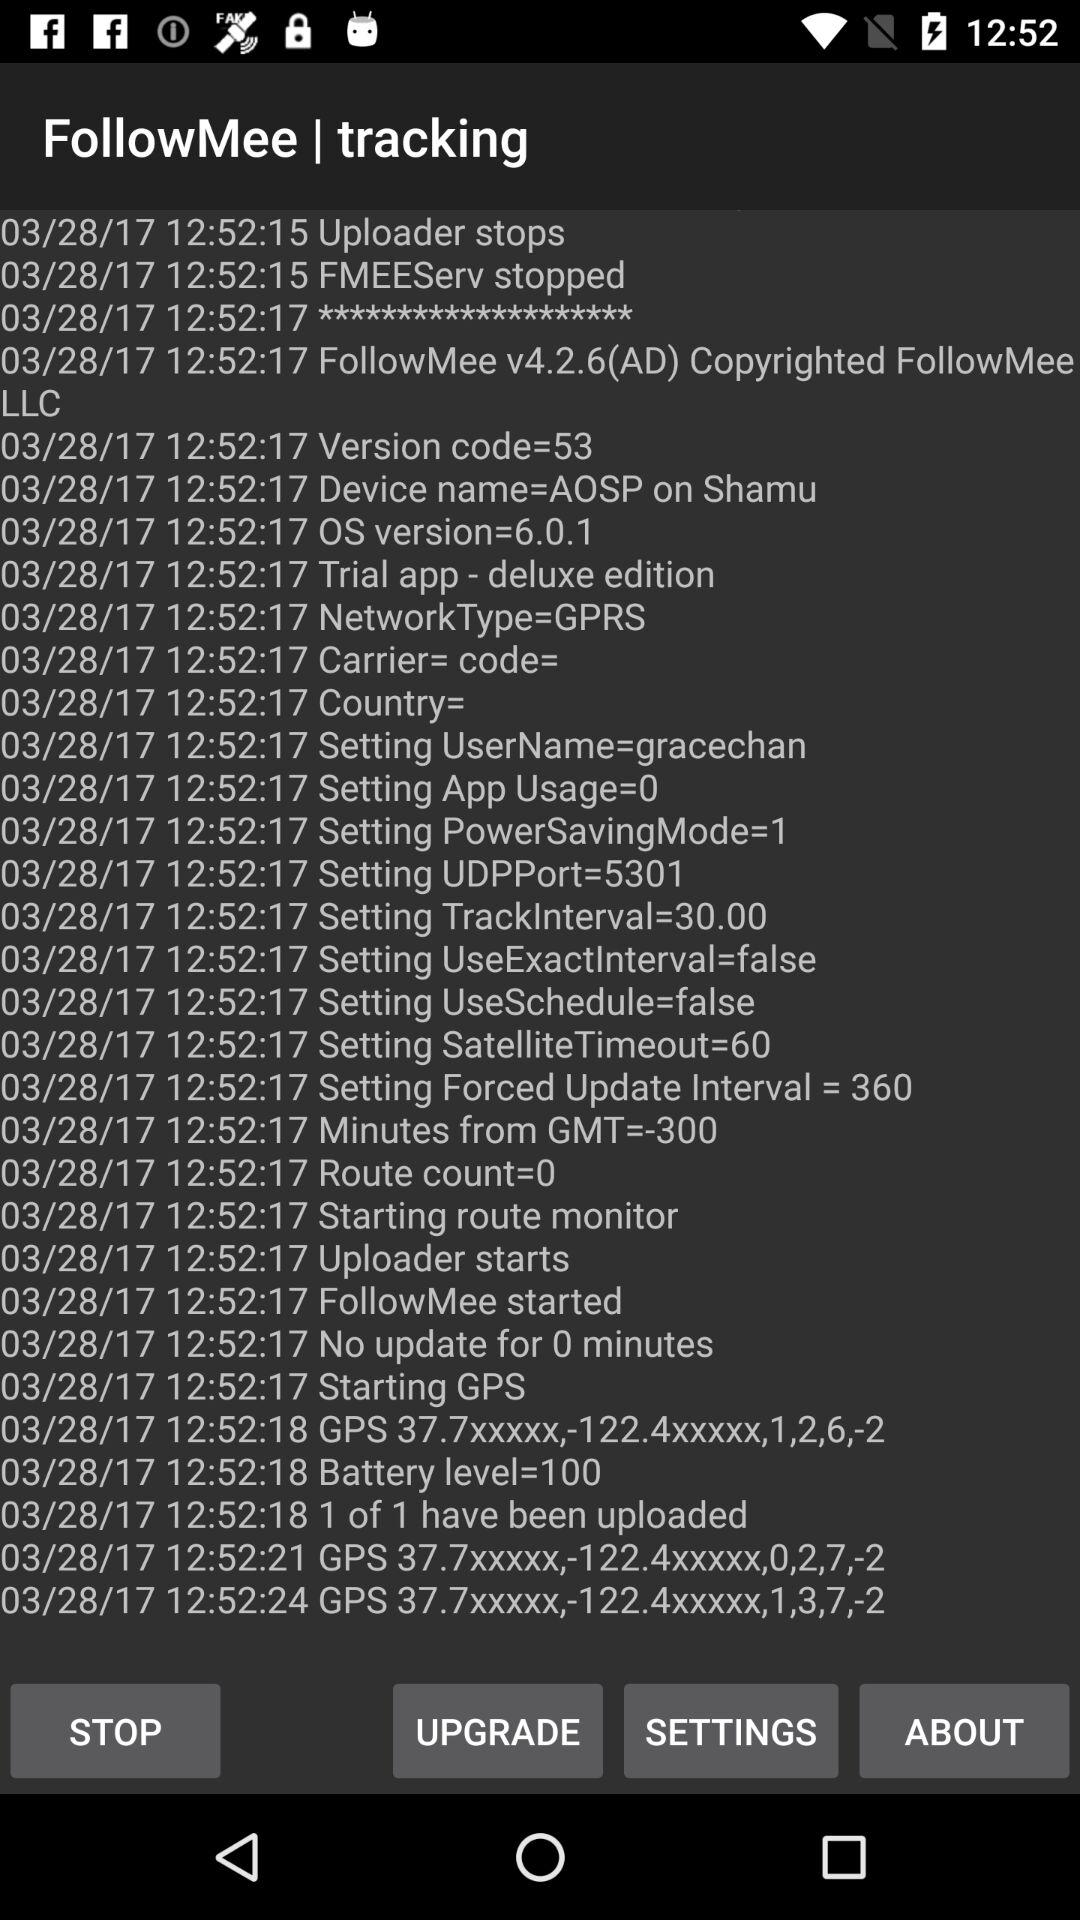What is the name of the application? The name of the application is "FollowMee". 